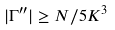<formula> <loc_0><loc_0><loc_500><loc_500>| \Gamma ^ { \prime \prime } | \geq N / 5 K ^ { 3 }</formula> 